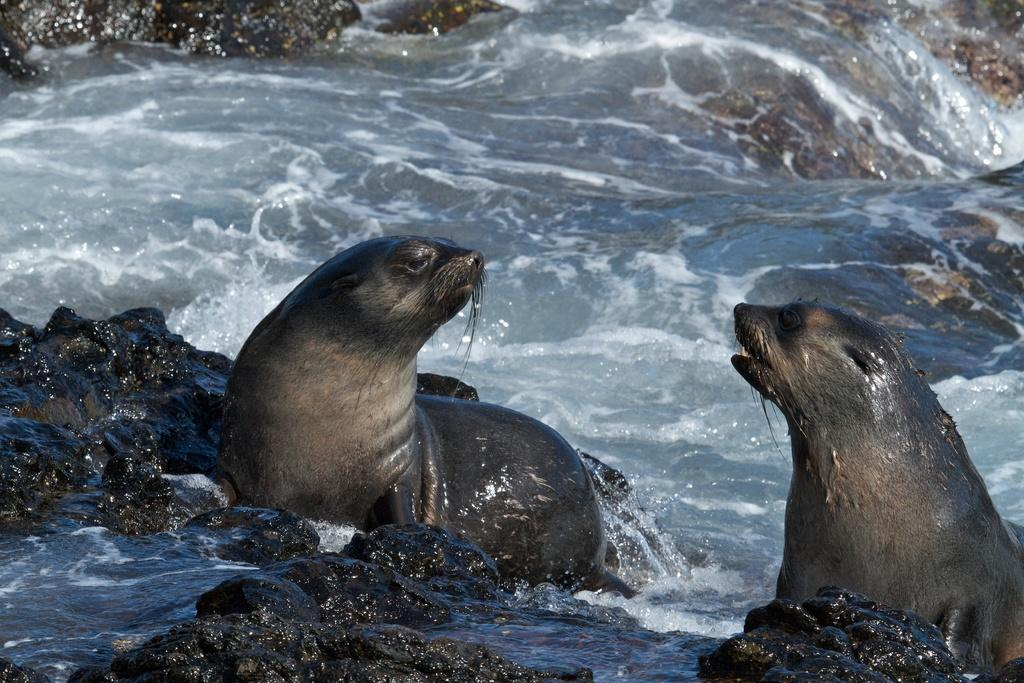How many seals are in the image? There are two seals in the image. What else can be seen in the image besides the seals? There are rocks visible in the image. What is visible in the background of the image? There is water visible in the background of the image. What type of pies are being served at the beach in the image? There are no pies present in the image; it features two seals and rocks near water. Can you describe the wren's nest in the image? There is no wren or nest present in the image. 